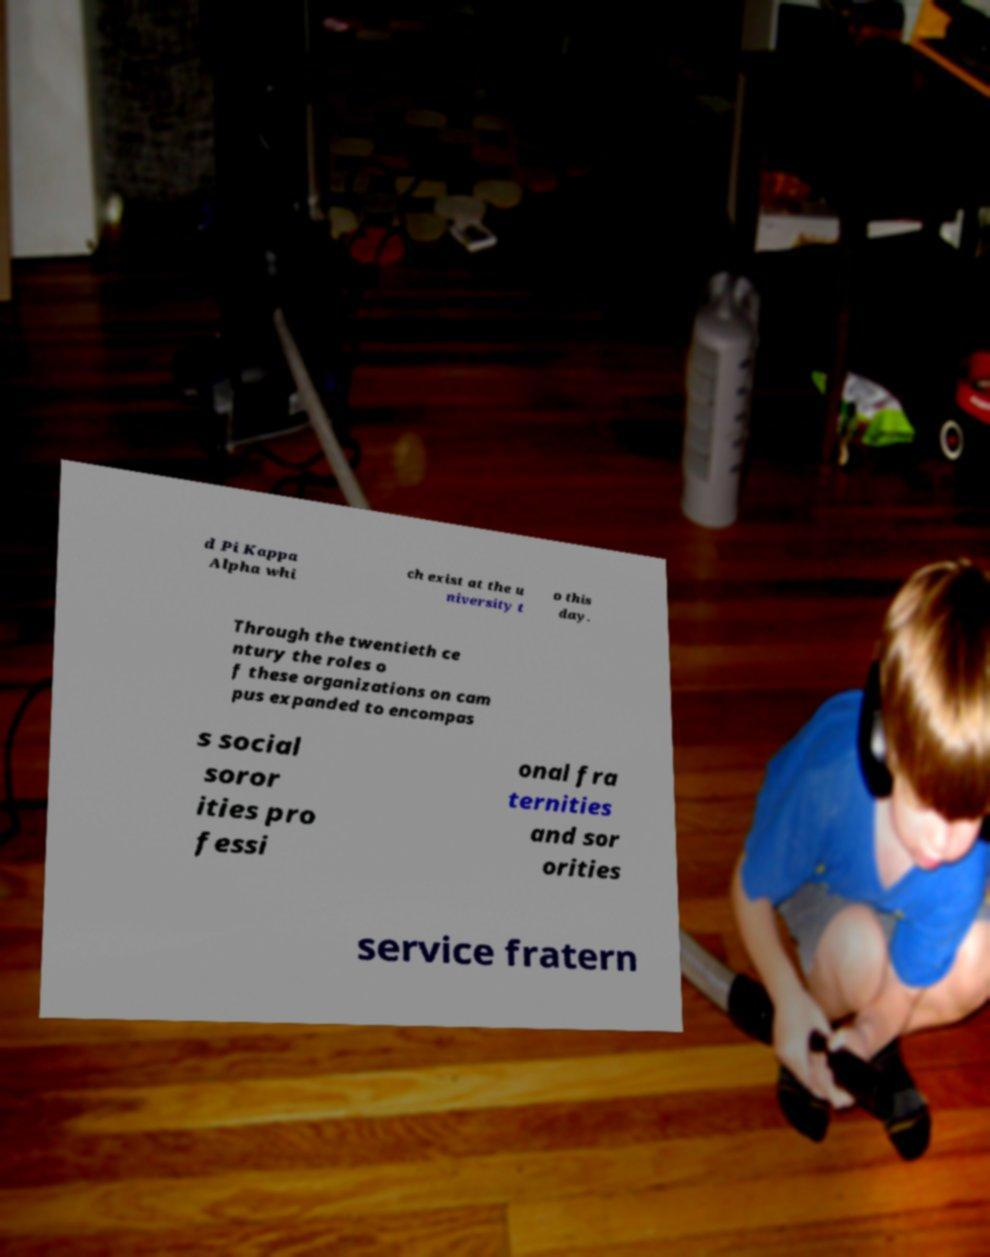There's text embedded in this image that I need extracted. Can you transcribe it verbatim? d Pi Kappa Alpha whi ch exist at the u niversity t o this day. Through the twentieth ce ntury the roles o f these organizations on cam pus expanded to encompas s social soror ities pro fessi onal fra ternities and sor orities service fratern 